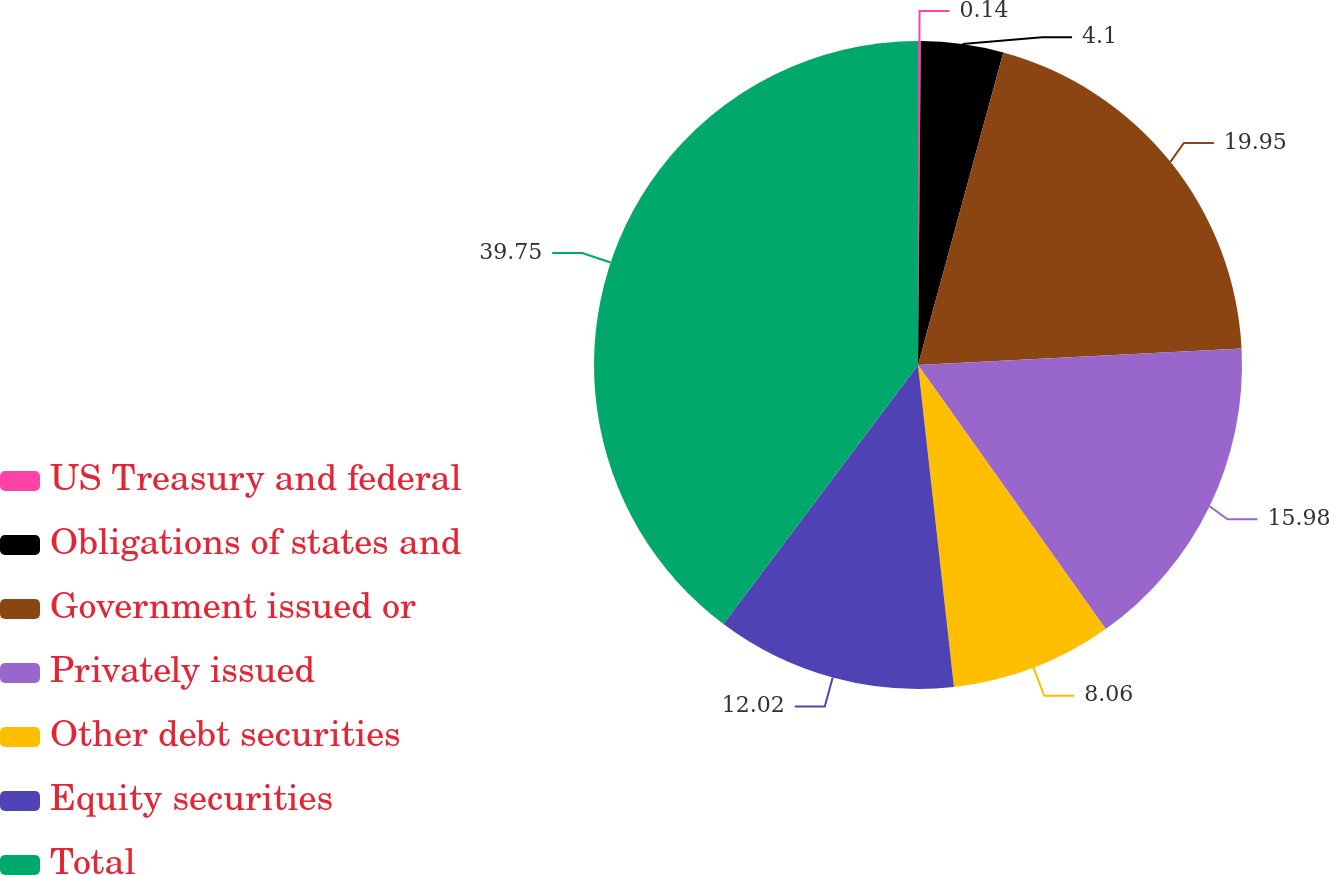Convert chart to OTSL. <chart><loc_0><loc_0><loc_500><loc_500><pie_chart><fcel>US Treasury and federal<fcel>Obligations of states and<fcel>Government issued or<fcel>Privately issued<fcel>Other debt securities<fcel>Equity securities<fcel>Total<nl><fcel>0.14%<fcel>4.1%<fcel>19.94%<fcel>15.98%<fcel>8.06%<fcel>12.02%<fcel>39.74%<nl></chart> 